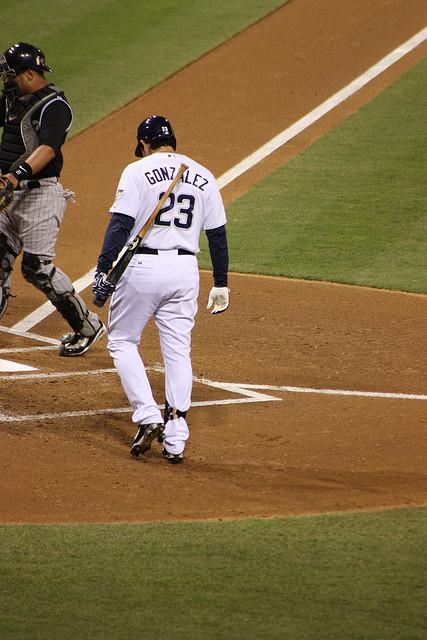Are they standing on the grass?
Concise answer only. No. How many players are in the picture?
Answer briefly. 2. Do you think that guy is from Japan?
Short answer required. No. What number is on the players jersey?
Be succinct. 23. 